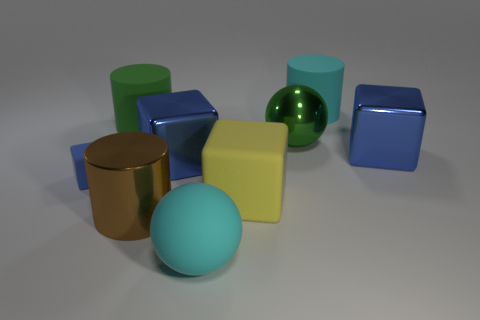Subtract all small cubes. How many cubes are left? 3 Subtract all gray cylinders. How many blue blocks are left? 3 Subtract all yellow cubes. How many cubes are left? 3 Subtract all cubes. How many objects are left? 5 Subtract 1 spheres. How many spheres are left? 1 Add 2 large green rubber cylinders. How many large green rubber cylinders exist? 3 Subtract 0 purple balls. How many objects are left? 9 Subtract all cyan balls. Subtract all purple cubes. How many balls are left? 1 Subtract all yellow cylinders. Subtract all cyan cylinders. How many objects are left? 8 Add 9 tiny rubber blocks. How many tiny rubber blocks are left? 10 